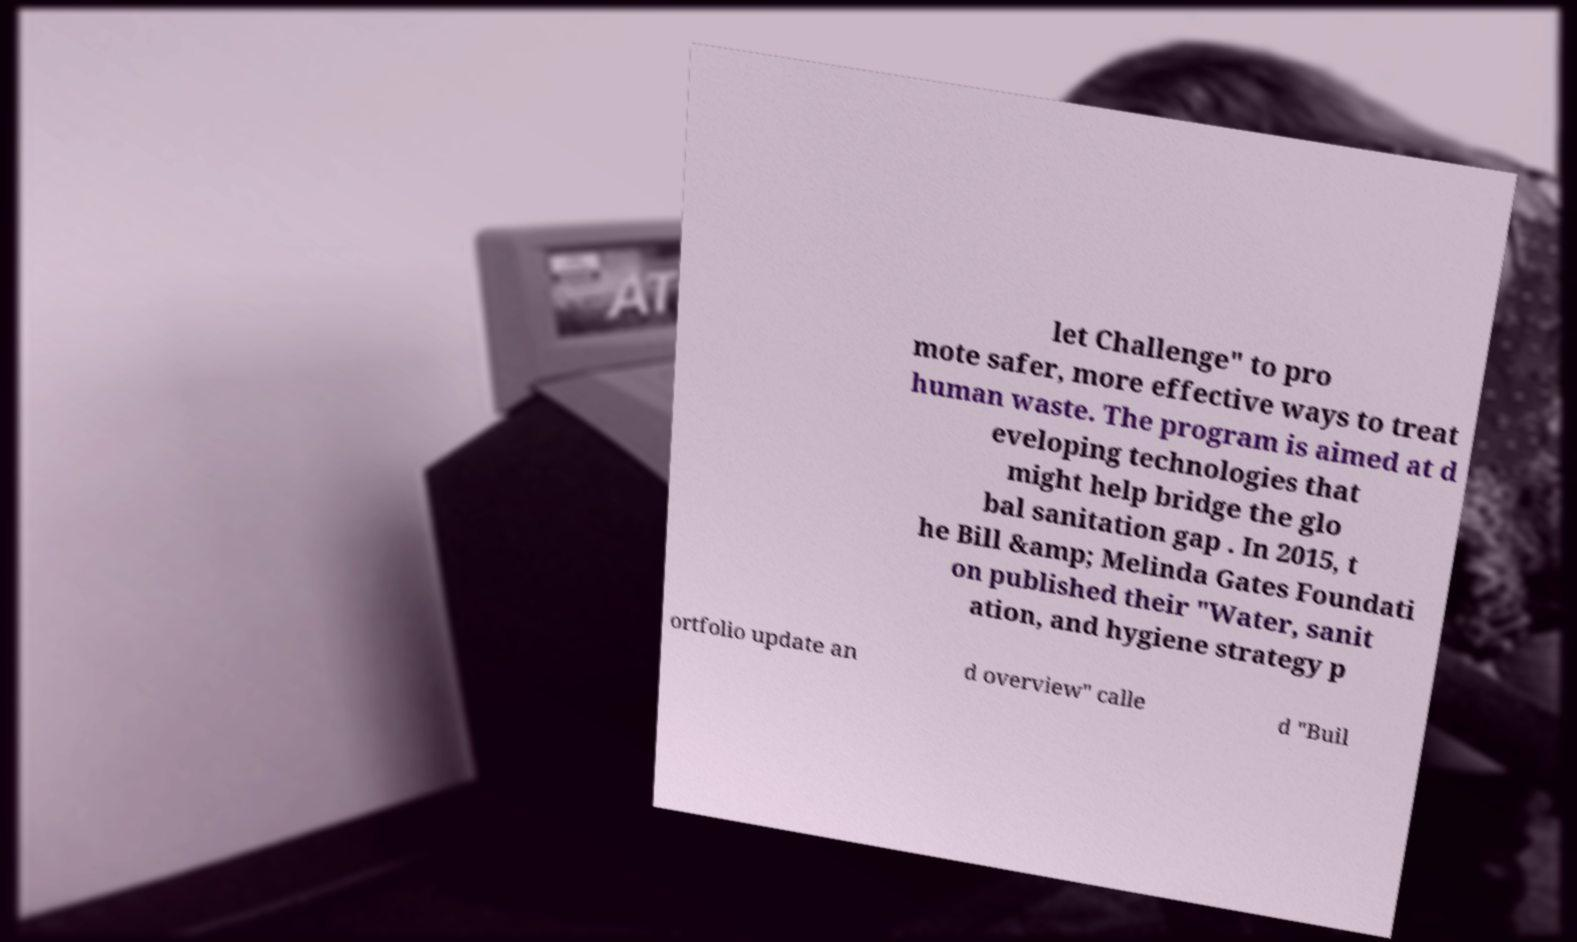Could you extract and type out the text from this image? let Challenge" to pro mote safer, more effective ways to treat human waste. The program is aimed at d eveloping technologies that might help bridge the glo bal sanitation gap . In 2015, t he Bill &amp; Melinda Gates Foundati on published their "Water, sanit ation, and hygiene strategy p ortfolio update an d overview" calle d "Buil 